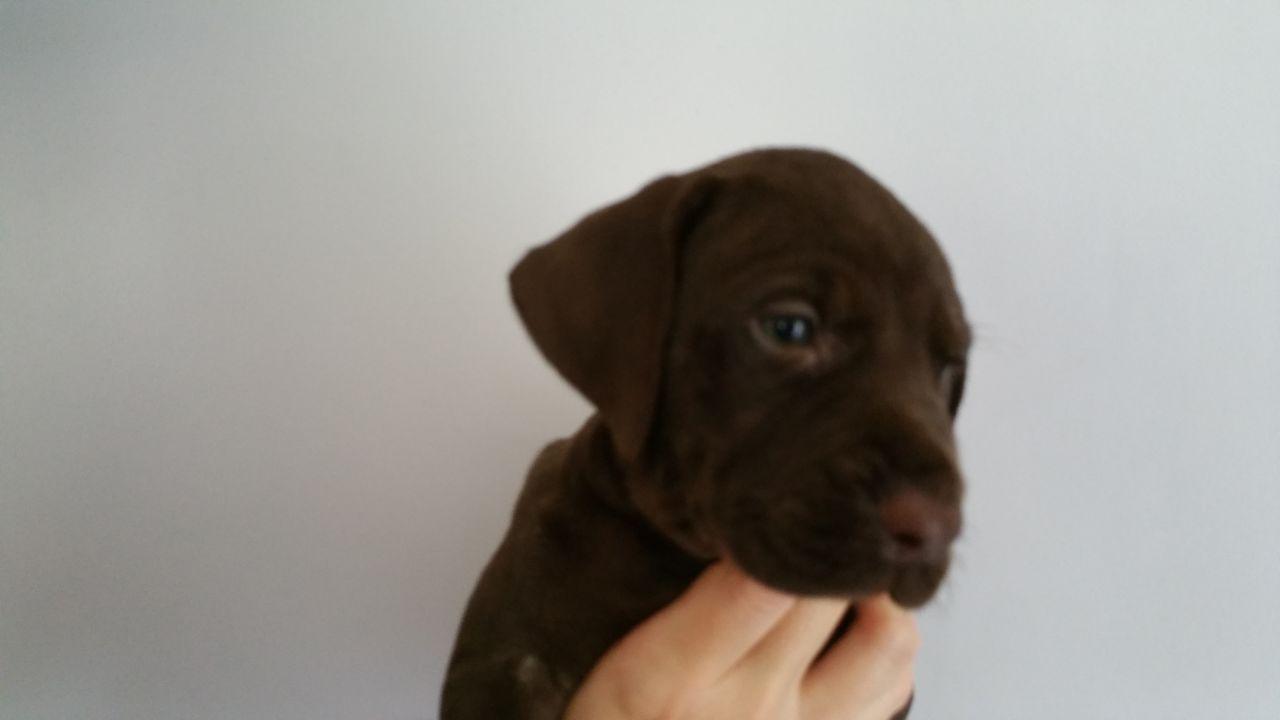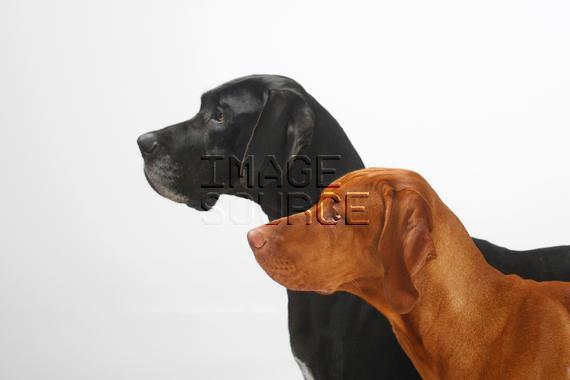The first image is the image on the left, the second image is the image on the right. Considering the images on both sides, is "At least one of the dogs is wearing something." valid? Answer yes or no. No. The first image is the image on the left, the second image is the image on the right. Evaluate the accuracy of this statement regarding the images: "The dogs in the left and right images face toward each other, and the combined images include a chocolate lab and and a red-orange lab.". Is it true? Answer yes or no. Yes. 